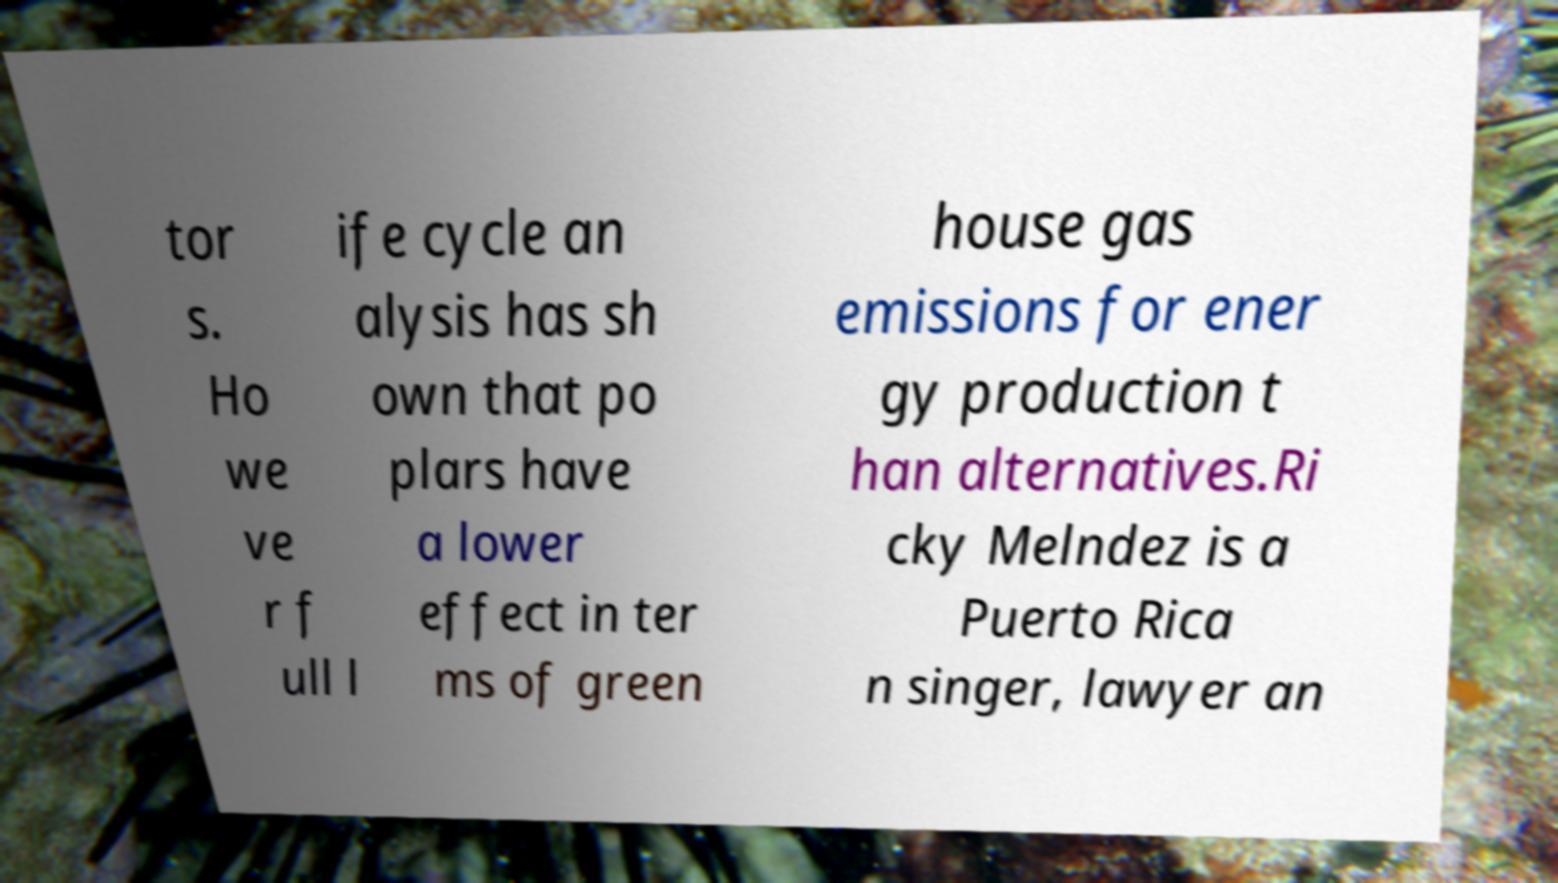I need the written content from this picture converted into text. Can you do that? tor s. Ho we ve r f ull l ife cycle an alysis has sh own that po plars have a lower effect in ter ms of green house gas emissions for ener gy production t han alternatives.Ri cky Melndez is a Puerto Rica n singer, lawyer an 